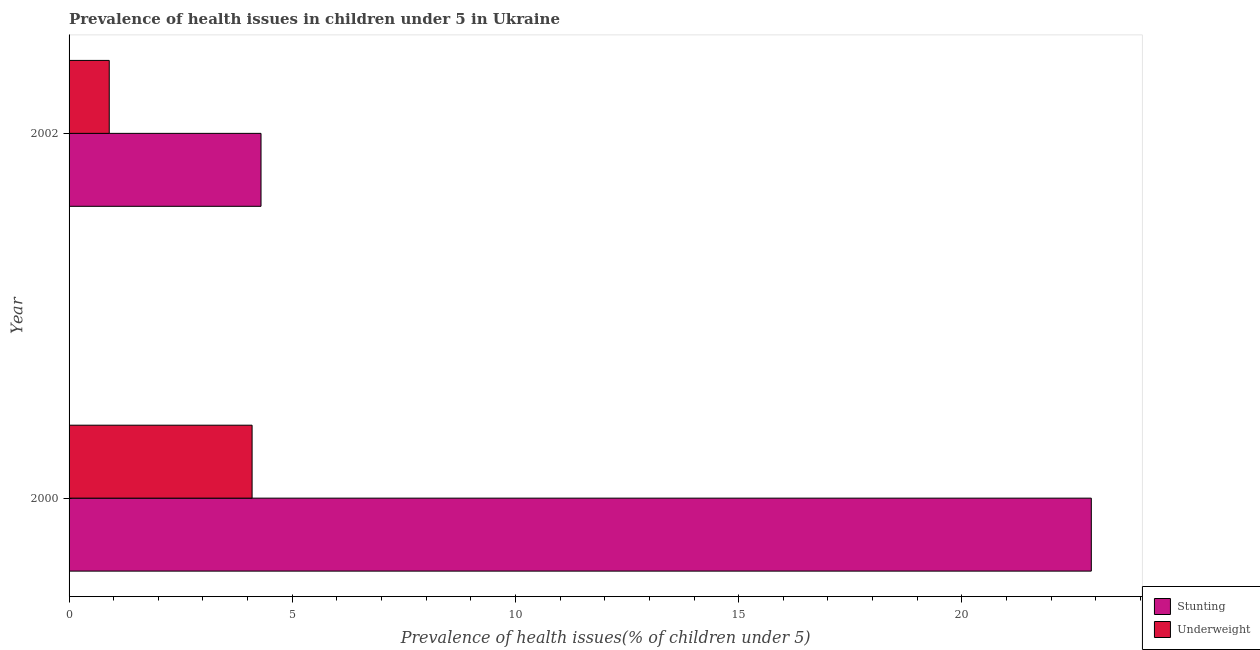How many different coloured bars are there?
Keep it short and to the point. 2. How many groups of bars are there?
Keep it short and to the point. 2. Are the number of bars per tick equal to the number of legend labels?
Ensure brevity in your answer.  Yes. How many bars are there on the 1st tick from the top?
Your answer should be compact. 2. What is the label of the 2nd group of bars from the top?
Your answer should be very brief. 2000. In how many cases, is the number of bars for a given year not equal to the number of legend labels?
Give a very brief answer. 0. What is the percentage of stunted children in 2000?
Ensure brevity in your answer.  22.9. Across all years, what is the maximum percentage of underweight children?
Make the answer very short. 4.1. Across all years, what is the minimum percentage of stunted children?
Your response must be concise. 4.3. In which year was the percentage of stunted children maximum?
Your response must be concise. 2000. What is the total percentage of underweight children in the graph?
Your answer should be very brief. 5. What is the difference between the percentage of stunted children in 2000 and the percentage of underweight children in 2002?
Your answer should be compact. 22. In the year 2000, what is the difference between the percentage of stunted children and percentage of underweight children?
Give a very brief answer. 18.8. In how many years, is the percentage of underweight children greater than 14 %?
Keep it short and to the point. 0. What is the ratio of the percentage of stunted children in 2000 to that in 2002?
Your answer should be compact. 5.33. Is the difference between the percentage of underweight children in 2000 and 2002 greater than the difference between the percentage of stunted children in 2000 and 2002?
Make the answer very short. No. What does the 1st bar from the top in 2002 represents?
Make the answer very short. Underweight. What does the 2nd bar from the bottom in 2002 represents?
Make the answer very short. Underweight. How many bars are there?
Offer a very short reply. 4. How many years are there in the graph?
Offer a very short reply. 2. Does the graph contain any zero values?
Offer a very short reply. No. How many legend labels are there?
Offer a terse response. 2. How are the legend labels stacked?
Offer a very short reply. Vertical. What is the title of the graph?
Your answer should be compact. Prevalence of health issues in children under 5 in Ukraine. What is the label or title of the X-axis?
Give a very brief answer. Prevalence of health issues(% of children under 5). What is the Prevalence of health issues(% of children under 5) of Stunting in 2000?
Your response must be concise. 22.9. What is the Prevalence of health issues(% of children under 5) in Underweight in 2000?
Ensure brevity in your answer.  4.1. What is the Prevalence of health issues(% of children under 5) in Stunting in 2002?
Your answer should be very brief. 4.3. What is the Prevalence of health issues(% of children under 5) of Underweight in 2002?
Your response must be concise. 0.9. Across all years, what is the maximum Prevalence of health issues(% of children under 5) of Stunting?
Your response must be concise. 22.9. Across all years, what is the maximum Prevalence of health issues(% of children under 5) in Underweight?
Give a very brief answer. 4.1. Across all years, what is the minimum Prevalence of health issues(% of children under 5) in Stunting?
Your answer should be compact. 4.3. Across all years, what is the minimum Prevalence of health issues(% of children under 5) in Underweight?
Keep it short and to the point. 0.9. What is the total Prevalence of health issues(% of children under 5) of Stunting in the graph?
Provide a short and direct response. 27.2. What is the difference between the Prevalence of health issues(% of children under 5) of Stunting in 2000 and that in 2002?
Give a very brief answer. 18.6. What is the difference between the Prevalence of health issues(% of children under 5) of Stunting in 2000 and the Prevalence of health issues(% of children under 5) of Underweight in 2002?
Ensure brevity in your answer.  22. What is the average Prevalence of health issues(% of children under 5) in Stunting per year?
Your answer should be compact. 13.6. In the year 2002, what is the difference between the Prevalence of health issues(% of children under 5) of Stunting and Prevalence of health issues(% of children under 5) of Underweight?
Your answer should be compact. 3.4. What is the ratio of the Prevalence of health issues(% of children under 5) in Stunting in 2000 to that in 2002?
Give a very brief answer. 5.33. What is the ratio of the Prevalence of health issues(% of children under 5) of Underweight in 2000 to that in 2002?
Offer a terse response. 4.56. What is the difference between the highest and the lowest Prevalence of health issues(% of children under 5) of Stunting?
Your answer should be very brief. 18.6. 